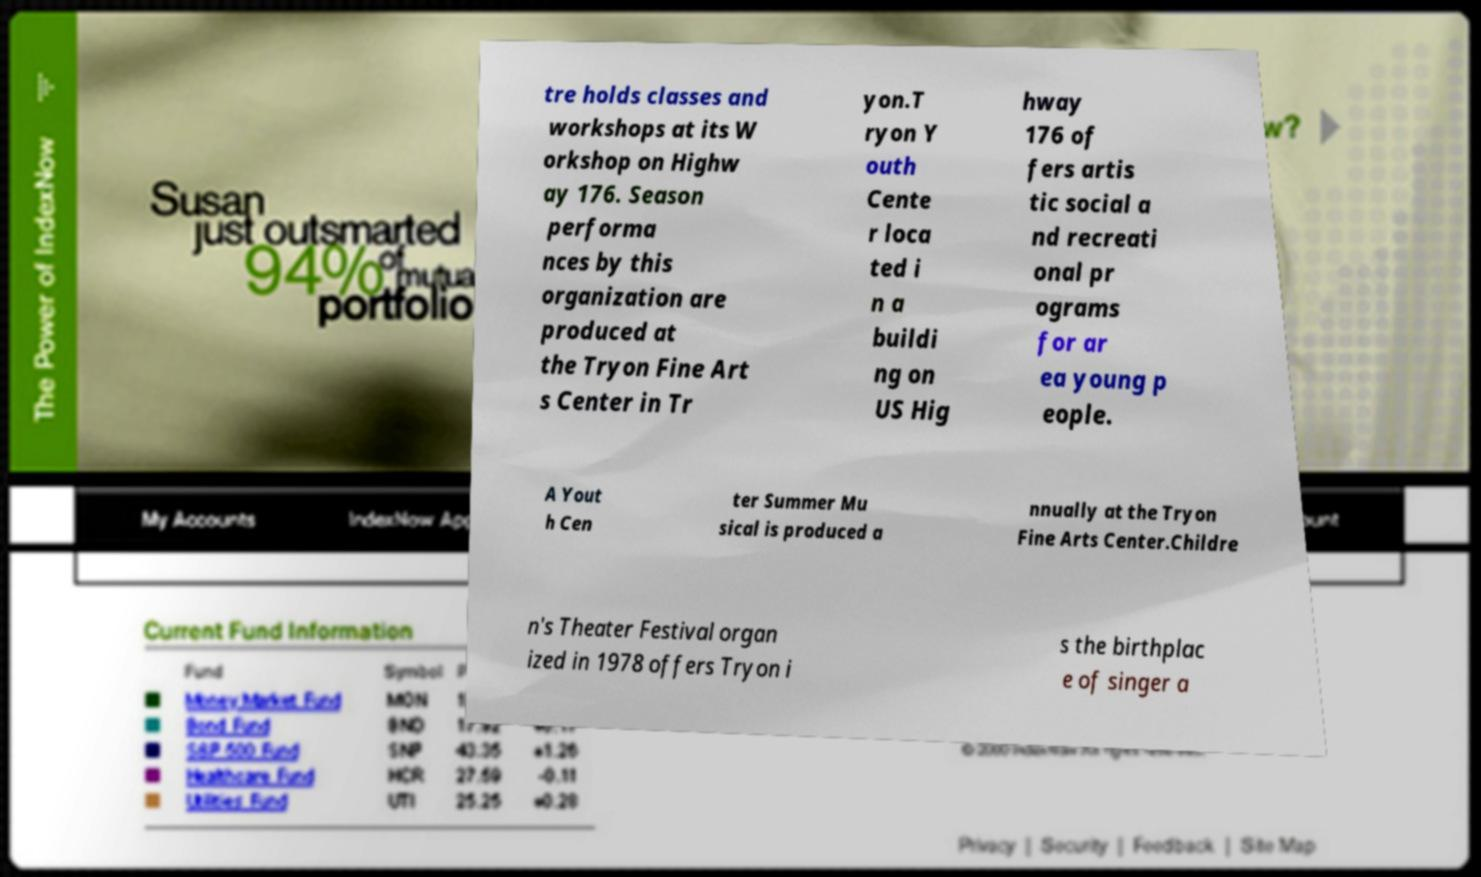Could you extract and type out the text from this image? tre holds classes and workshops at its W orkshop on Highw ay 176. Season performa nces by this organization are produced at the Tryon Fine Art s Center in Tr yon.T ryon Y outh Cente r loca ted i n a buildi ng on US Hig hway 176 of fers artis tic social a nd recreati onal pr ograms for ar ea young p eople. A Yout h Cen ter Summer Mu sical is produced a nnually at the Tryon Fine Arts Center.Childre n's Theater Festival organ ized in 1978 offers Tryon i s the birthplac e of singer a 